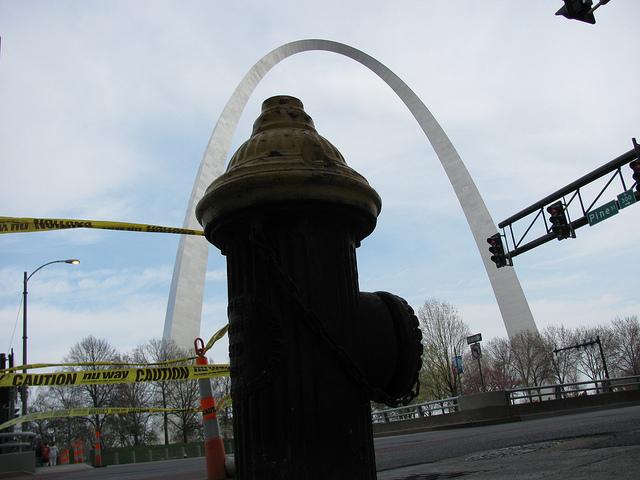Is this in St. Louis?
Concise answer only. Yes. What is in the front middle of the picture?
Be succinct. Fire hydrant. What street is on the sign?
Give a very brief answer. Pine. 